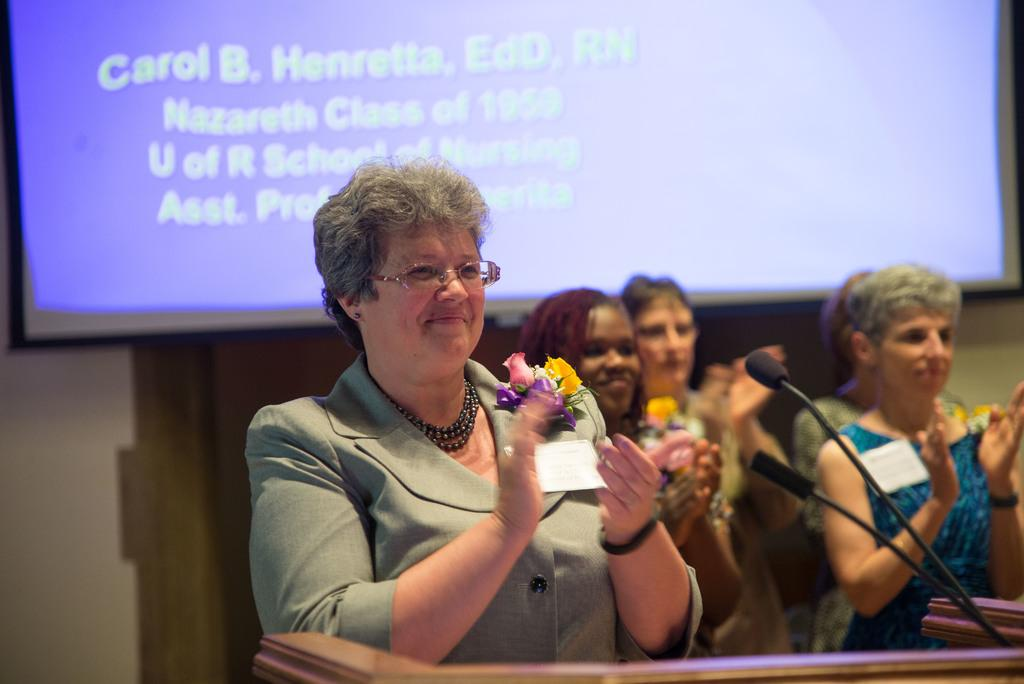What are the women in the image doing? The women are standing and clapping their hands. What can be seen in the background of the image? There is a podium, at least one microphone, and a display in the background of the image. What might be the purpose of the podium in the image? The podium might be used for someone to stand and speak or present. Can you hear the women laughing on the farm in the image? There is no reference to a farm or laughter in the image; it features women standing and clapping their hands with a podium, microphone, and display in the background. 